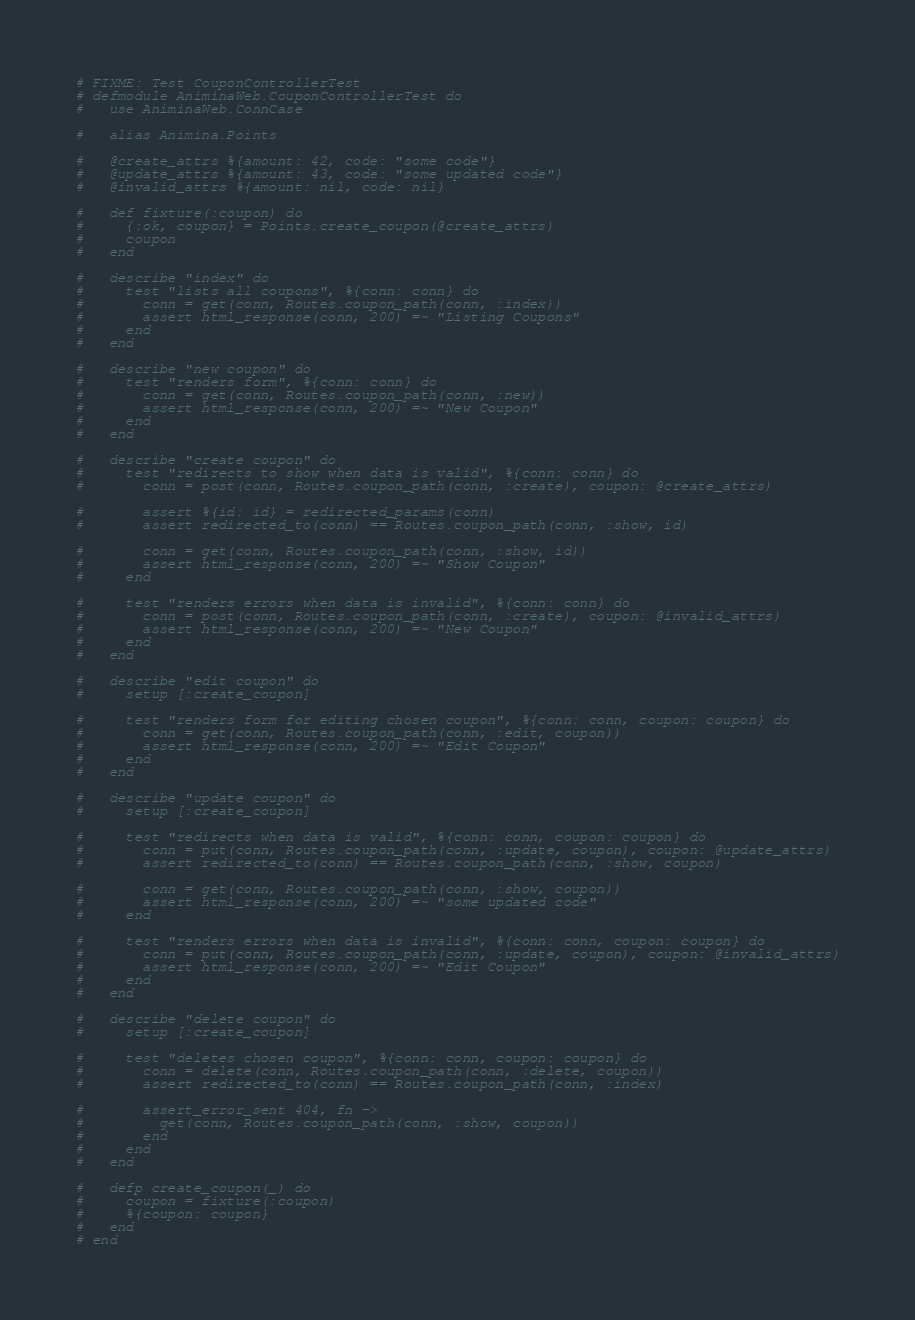Convert code to text. <code><loc_0><loc_0><loc_500><loc_500><_Elixir_># FIXME: Test CouponControllerTest
# defmodule AniminaWeb.CouponControllerTest do
#   use AniminaWeb.ConnCase

#   alias Animina.Points

#   @create_attrs %{amount: 42, code: "some code"}
#   @update_attrs %{amount: 43, code: "some updated code"}
#   @invalid_attrs %{amount: nil, code: nil}

#   def fixture(:coupon) do
#     {:ok, coupon} = Points.create_coupon(@create_attrs)
#     coupon
#   end

#   describe "index" do
#     test "lists all coupons", %{conn: conn} do
#       conn = get(conn, Routes.coupon_path(conn, :index))
#       assert html_response(conn, 200) =~ "Listing Coupons"
#     end
#   end

#   describe "new coupon" do
#     test "renders form", %{conn: conn} do
#       conn = get(conn, Routes.coupon_path(conn, :new))
#       assert html_response(conn, 200) =~ "New Coupon"
#     end
#   end

#   describe "create coupon" do
#     test "redirects to show when data is valid", %{conn: conn} do
#       conn = post(conn, Routes.coupon_path(conn, :create), coupon: @create_attrs)

#       assert %{id: id} = redirected_params(conn)
#       assert redirected_to(conn) == Routes.coupon_path(conn, :show, id)

#       conn = get(conn, Routes.coupon_path(conn, :show, id))
#       assert html_response(conn, 200) =~ "Show Coupon"
#     end

#     test "renders errors when data is invalid", %{conn: conn} do
#       conn = post(conn, Routes.coupon_path(conn, :create), coupon: @invalid_attrs)
#       assert html_response(conn, 200) =~ "New Coupon"
#     end
#   end

#   describe "edit coupon" do
#     setup [:create_coupon]

#     test "renders form for editing chosen coupon", %{conn: conn, coupon: coupon} do
#       conn = get(conn, Routes.coupon_path(conn, :edit, coupon))
#       assert html_response(conn, 200) =~ "Edit Coupon"
#     end
#   end

#   describe "update coupon" do
#     setup [:create_coupon]

#     test "redirects when data is valid", %{conn: conn, coupon: coupon} do
#       conn = put(conn, Routes.coupon_path(conn, :update, coupon), coupon: @update_attrs)
#       assert redirected_to(conn) == Routes.coupon_path(conn, :show, coupon)

#       conn = get(conn, Routes.coupon_path(conn, :show, coupon))
#       assert html_response(conn, 200) =~ "some updated code"
#     end

#     test "renders errors when data is invalid", %{conn: conn, coupon: coupon} do
#       conn = put(conn, Routes.coupon_path(conn, :update, coupon), coupon: @invalid_attrs)
#       assert html_response(conn, 200) =~ "Edit Coupon"
#     end
#   end

#   describe "delete coupon" do
#     setup [:create_coupon]

#     test "deletes chosen coupon", %{conn: conn, coupon: coupon} do
#       conn = delete(conn, Routes.coupon_path(conn, :delete, coupon))
#       assert redirected_to(conn) == Routes.coupon_path(conn, :index)

#       assert_error_sent 404, fn ->
#         get(conn, Routes.coupon_path(conn, :show, coupon))
#       end
#     end
#   end

#   defp create_coupon(_) do
#     coupon = fixture(:coupon)
#     %{coupon: coupon}
#   end
# end
</code> 